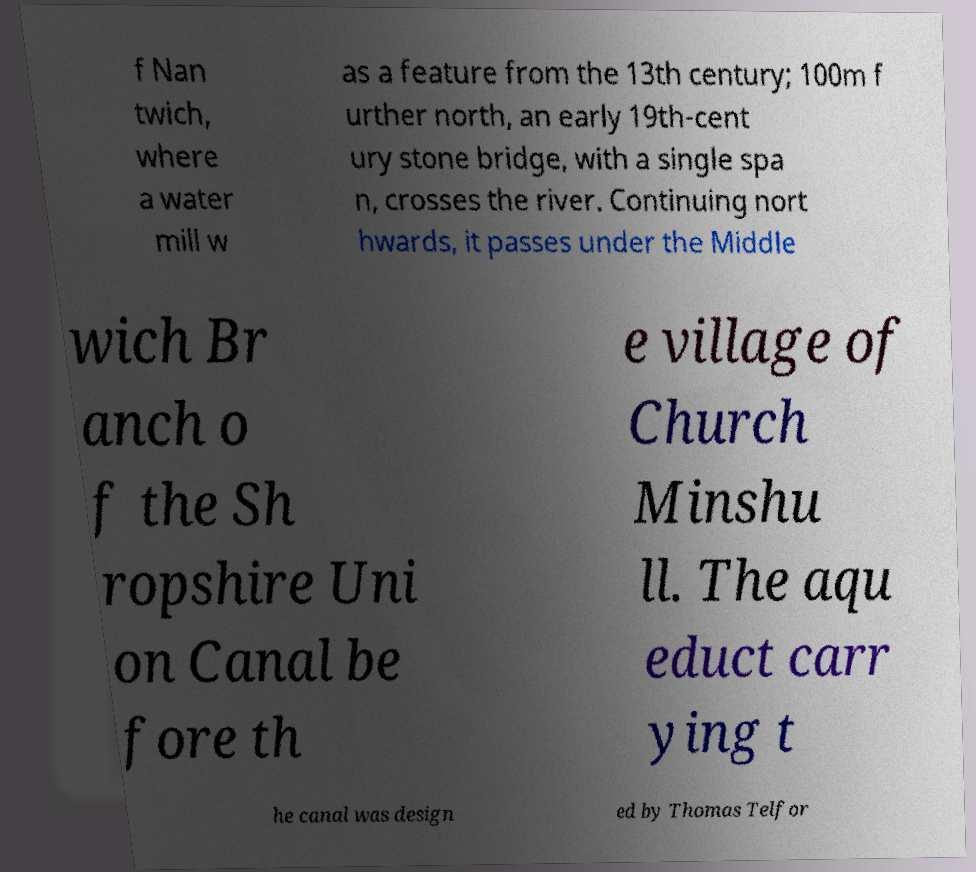What messages or text are displayed in this image? I need them in a readable, typed format. f Nan twich, where a water mill w as a feature from the 13th century; 100m f urther north, an early 19th-cent ury stone bridge, with a single spa n, crosses the river. Continuing nort hwards, it passes under the Middle wich Br anch o f the Sh ropshire Uni on Canal be fore th e village of Church Minshu ll. The aqu educt carr ying t he canal was design ed by Thomas Telfor 